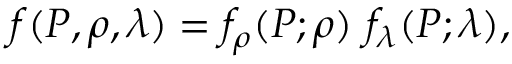Convert formula to latex. <formula><loc_0><loc_0><loc_500><loc_500>f ( P , \rho , \lambda ) = f _ { \rho } ( P ; \rho ) f _ { \lambda } ( P ; \lambda ) ,</formula> 